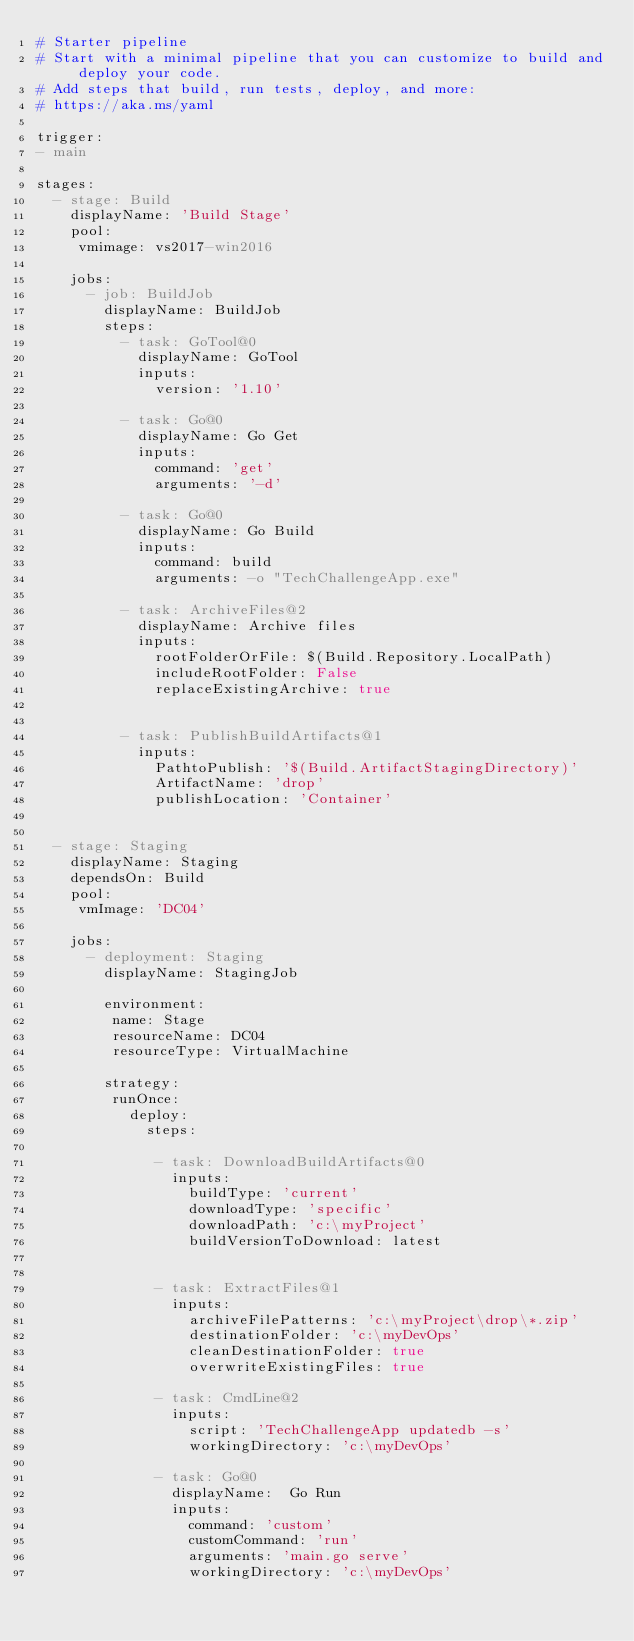Convert code to text. <code><loc_0><loc_0><loc_500><loc_500><_YAML_># Starter pipeline
# Start with a minimal pipeline that you can customize to build and deploy your code.
# Add steps that build, run tests, deploy, and more:
# https://aka.ms/yaml

trigger:
- main

stages:
  - stage: Build
    displayName: 'Build Stage'
    pool:
     vmimage: vs2017-win2016
     
    jobs:
      - job: BuildJob
        displayName: BuildJob
        steps:
          - task: GoTool@0
            displayName: GoTool
            inputs:
              version: '1.10'
          
          - task: Go@0
            displayName: Go Get
            inputs:
              command: 'get'
              arguments: '-d'

          - task: Go@0
            displayName: Go Build
            inputs:
              command: build
              arguments: -o "TechChallengeApp.exe"
            
          - task: ArchiveFiles@2
            displayName: Archive files
            inputs:
              rootFolderOrFile: $(Build.Repository.LocalPath)
              includeRootFolder: False
              replaceExistingArchive: true

          
          - task: PublishBuildArtifacts@1
            inputs:
              PathtoPublish: '$(Build.ArtifactStagingDirectory)'
              ArtifactName: 'drop'
              publishLocation: 'Container'
              
              
  - stage: Staging
    displayName: Staging
    dependsOn: Build
    pool:
     vmImage: 'DC04'
    
    jobs:
      - deployment: Staging
        displayName: StagingJob

        environment:
         name: Stage
         resourceName: DC04
         resourceType: VirtualMachine

        strategy:
         runOnce:
           deploy:
             steps:

              - task: DownloadBuildArtifacts@0
                inputs:
                  buildType: 'current'
                  downloadType: 'specific'
                  downloadPath: 'c:\myProject'
                  buildVersionToDownload: latest
                

              - task: ExtractFiles@1
                inputs:
                  archiveFilePatterns: 'c:\myProject\drop\*.zip'
                  destinationFolder: 'c:\myDevOps'
                  cleanDestinationFolder: true
                  overwriteExistingFiles: true

              - task: CmdLine@2
                inputs:
                  script: 'TechChallengeApp updatedb -s'
                  workingDirectory: 'c:\myDevOps'          

              - task: Go@0
                displayName:  Go Run
                inputs:
                  command: 'custom'
                  customCommand: 'run'
                  arguments: 'main.go serve'
                  workingDirectory: 'c:\myDevOps'
              
</code> 